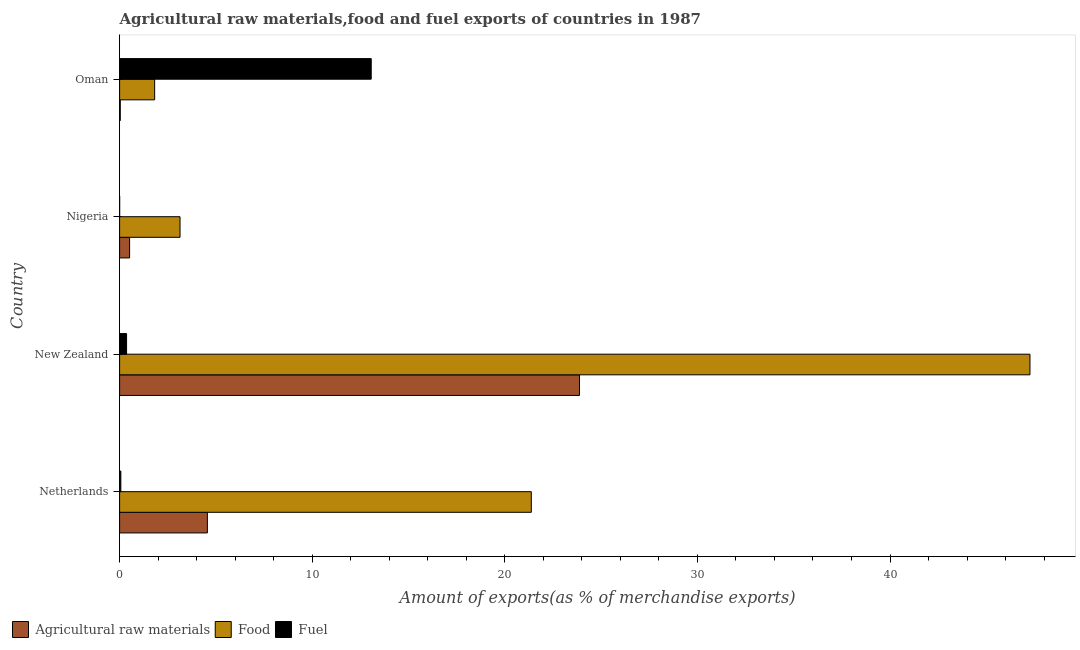How many different coloured bars are there?
Ensure brevity in your answer.  3. How many groups of bars are there?
Provide a short and direct response. 4. Are the number of bars per tick equal to the number of legend labels?
Offer a very short reply. Yes. Are the number of bars on each tick of the Y-axis equal?
Make the answer very short. Yes. How many bars are there on the 1st tick from the top?
Give a very brief answer. 3. What is the label of the 4th group of bars from the top?
Ensure brevity in your answer.  Netherlands. In how many cases, is the number of bars for a given country not equal to the number of legend labels?
Give a very brief answer. 0. What is the percentage of raw materials exports in New Zealand?
Your answer should be very brief. 23.88. Across all countries, what is the maximum percentage of fuel exports?
Keep it short and to the point. 13.06. Across all countries, what is the minimum percentage of raw materials exports?
Ensure brevity in your answer.  0.04. In which country was the percentage of raw materials exports maximum?
Make the answer very short. New Zealand. In which country was the percentage of fuel exports minimum?
Offer a very short reply. Nigeria. What is the total percentage of fuel exports in the graph?
Your answer should be very brief. 13.49. What is the difference between the percentage of food exports in New Zealand and that in Oman?
Your response must be concise. 45.45. What is the difference between the percentage of food exports in Netherlands and the percentage of fuel exports in Oman?
Ensure brevity in your answer.  8.31. What is the average percentage of food exports per country?
Offer a very short reply. 18.4. What is the difference between the percentage of food exports and percentage of fuel exports in Nigeria?
Your answer should be very brief. 3.13. In how many countries, is the percentage of food exports greater than 46 %?
Keep it short and to the point. 1. What is the ratio of the percentage of raw materials exports in Netherlands to that in Nigeria?
Your answer should be very brief. 8.77. Is the difference between the percentage of food exports in Nigeria and Oman greater than the difference between the percentage of raw materials exports in Nigeria and Oman?
Provide a short and direct response. Yes. What is the difference between the highest and the second highest percentage of raw materials exports?
Your answer should be very brief. 19.32. What is the difference between the highest and the lowest percentage of raw materials exports?
Your answer should be compact. 23.84. In how many countries, is the percentage of fuel exports greater than the average percentage of fuel exports taken over all countries?
Your response must be concise. 1. What does the 3rd bar from the top in New Zealand represents?
Make the answer very short. Agricultural raw materials. What does the 3rd bar from the bottom in New Zealand represents?
Keep it short and to the point. Fuel. Are all the bars in the graph horizontal?
Your answer should be very brief. Yes. Are the values on the major ticks of X-axis written in scientific E-notation?
Keep it short and to the point. No. Does the graph contain any zero values?
Offer a very short reply. No. Does the graph contain grids?
Keep it short and to the point. No. Where does the legend appear in the graph?
Your answer should be compact. Bottom left. How many legend labels are there?
Your response must be concise. 3. What is the title of the graph?
Make the answer very short. Agricultural raw materials,food and fuel exports of countries in 1987. What is the label or title of the X-axis?
Keep it short and to the point. Amount of exports(as % of merchandise exports). What is the Amount of exports(as % of merchandise exports) of Agricultural raw materials in Netherlands?
Offer a terse response. 4.56. What is the Amount of exports(as % of merchandise exports) in Food in Netherlands?
Ensure brevity in your answer.  21.38. What is the Amount of exports(as % of merchandise exports) in Fuel in Netherlands?
Make the answer very short. 0.06. What is the Amount of exports(as % of merchandise exports) in Agricultural raw materials in New Zealand?
Provide a succinct answer. 23.88. What is the Amount of exports(as % of merchandise exports) of Food in New Zealand?
Your response must be concise. 47.27. What is the Amount of exports(as % of merchandise exports) of Fuel in New Zealand?
Provide a short and direct response. 0.36. What is the Amount of exports(as % of merchandise exports) in Agricultural raw materials in Nigeria?
Offer a very short reply. 0.52. What is the Amount of exports(as % of merchandise exports) in Food in Nigeria?
Ensure brevity in your answer.  3.14. What is the Amount of exports(as % of merchandise exports) of Fuel in Nigeria?
Make the answer very short. 0. What is the Amount of exports(as % of merchandise exports) of Agricultural raw materials in Oman?
Give a very brief answer. 0.04. What is the Amount of exports(as % of merchandise exports) in Food in Oman?
Keep it short and to the point. 1.82. What is the Amount of exports(as % of merchandise exports) in Fuel in Oman?
Your answer should be compact. 13.06. Across all countries, what is the maximum Amount of exports(as % of merchandise exports) in Agricultural raw materials?
Offer a very short reply. 23.88. Across all countries, what is the maximum Amount of exports(as % of merchandise exports) of Food?
Offer a terse response. 47.27. Across all countries, what is the maximum Amount of exports(as % of merchandise exports) of Fuel?
Your answer should be very brief. 13.06. Across all countries, what is the minimum Amount of exports(as % of merchandise exports) in Agricultural raw materials?
Offer a very short reply. 0.04. Across all countries, what is the minimum Amount of exports(as % of merchandise exports) in Food?
Your answer should be very brief. 1.82. Across all countries, what is the minimum Amount of exports(as % of merchandise exports) in Fuel?
Ensure brevity in your answer.  0. What is the total Amount of exports(as % of merchandise exports) in Agricultural raw materials in the graph?
Provide a short and direct response. 28.99. What is the total Amount of exports(as % of merchandise exports) of Food in the graph?
Offer a terse response. 73.6. What is the total Amount of exports(as % of merchandise exports) in Fuel in the graph?
Your response must be concise. 13.49. What is the difference between the Amount of exports(as % of merchandise exports) of Agricultural raw materials in Netherlands and that in New Zealand?
Make the answer very short. -19.32. What is the difference between the Amount of exports(as % of merchandise exports) of Food in Netherlands and that in New Zealand?
Your response must be concise. -25.89. What is the difference between the Amount of exports(as % of merchandise exports) of Fuel in Netherlands and that in New Zealand?
Your response must be concise. -0.3. What is the difference between the Amount of exports(as % of merchandise exports) of Agricultural raw materials in Netherlands and that in Nigeria?
Offer a terse response. 4.04. What is the difference between the Amount of exports(as % of merchandise exports) of Food in Netherlands and that in Nigeria?
Your answer should be compact. 18.24. What is the difference between the Amount of exports(as % of merchandise exports) of Fuel in Netherlands and that in Nigeria?
Offer a terse response. 0.06. What is the difference between the Amount of exports(as % of merchandise exports) of Agricultural raw materials in Netherlands and that in Oman?
Keep it short and to the point. 4.52. What is the difference between the Amount of exports(as % of merchandise exports) in Food in Netherlands and that in Oman?
Provide a short and direct response. 19.56. What is the difference between the Amount of exports(as % of merchandise exports) in Fuel in Netherlands and that in Oman?
Make the answer very short. -13. What is the difference between the Amount of exports(as % of merchandise exports) in Agricultural raw materials in New Zealand and that in Nigeria?
Give a very brief answer. 23.36. What is the difference between the Amount of exports(as % of merchandise exports) in Food in New Zealand and that in Nigeria?
Give a very brief answer. 44.13. What is the difference between the Amount of exports(as % of merchandise exports) in Fuel in New Zealand and that in Nigeria?
Your answer should be very brief. 0.36. What is the difference between the Amount of exports(as % of merchandise exports) in Agricultural raw materials in New Zealand and that in Oman?
Your answer should be compact. 23.84. What is the difference between the Amount of exports(as % of merchandise exports) in Food in New Zealand and that in Oman?
Your response must be concise. 45.45. What is the difference between the Amount of exports(as % of merchandise exports) in Fuel in New Zealand and that in Oman?
Keep it short and to the point. -12.7. What is the difference between the Amount of exports(as % of merchandise exports) in Agricultural raw materials in Nigeria and that in Oman?
Offer a terse response. 0.48. What is the difference between the Amount of exports(as % of merchandise exports) of Food in Nigeria and that in Oman?
Provide a short and direct response. 1.32. What is the difference between the Amount of exports(as % of merchandise exports) of Fuel in Nigeria and that in Oman?
Offer a terse response. -13.06. What is the difference between the Amount of exports(as % of merchandise exports) of Agricultural raw materials in Netherlands and the Amount of exports(as % of merchandise exports) of Food in New Zealand?
Give a very brief answer. -42.71. What is the difference between the Amount of exports(as % of merchandise exports) in Agricultural raw materials in Netherlands and the Amount of exports(as % of merchandise exports) in Fuel in New Zealand?
Keep it short and to the point. 4.19. What is the difference between the Amount of exports(as % of merchandise exports) of Food in Netherlands and the Amount of exports(as % of merchandise exports) of Fuel in New Zealand?
Provide a succinct answer. 21.01. What is the difference between the Amount of exports(as % of merchandise exports) in Agricultural raw materials in Netherlands and the Amount of exports(as % of merchandise exports) in Food in Nigeria?
Provide a succinct answer. 1.42. What is the difference between the Amount of exports(as % of merchandise exports) of Agricultural raw materials in Netherlands and the Amount of exports(as % of merchandise exports) of Fuel in Nigeria?
Make the answer very short. 4.55. What is the difference between the Amount of exports(as % of merchandise exports) in Food in Netherlands and the Amount of exports(as % of merchandise exports) in Fuel in Nigeria?
Offer a terse response. 21.37. What is the difference between the Amount of exports(as % of merchandise exports) of Agricultural raw materials in Netherlands and the Amount of exports(as % of merchandise exports) of Food in Oman?
Provide a succinct answer. 2.74. What is the difference between the Amount of exports(as % of merchandise exports) in Agricultural raw materials in Netherlands and the Amount of exports(as % of merchandise exports) in Fuel in Oman?
Offer a terse response. -8.51. What is the difference between the Amount of exports(as % of merchandise exports) of Food in Netherlands and the Amount of exports(as % of merchandise exports) of Fuel in Oman?
Your response must be concise. 8.31. What is the difference between the Amount of exports(as % of merchandise exports) in Agricultural raw materials in New Zealand and the Amount of exports(as % of merchandise exports) in Food in Nigeria?
Provide a short and direct response. 20.74. What is the difference between the Amount of exports(as % of merchandise exports) in Agricultural raw materials in New Zealand and the Amount of exports(as % of merchandise exports) in Fuel in Nigeria?
Make the answer very short. 23.88. What is the difference between the Amount of exports(as % of merchandise exports) of Food in New Zealand and the Amount of exports(as % of merchandise exports) of Fuel in Nigeria?
Provide a succinct answer. 47.26. What is the difference between the Amount of exports(as % of merchandise exports) in Agricultural raw materials in New Zealand and the Amount of exports(as % of merchandise exports) in Food in Oman?
Your answer should be very brief. 22.06. What is the difference between the Amount of exports(as % of merchandise exports) in Agricultural raw materials in New Zealand and the Amount of exports(as % of merchandise exports) in Fuel in Oman?
Provide a succinct answer. 10.81. What is the difference between the Amount of exports(as % of merchandise exports) of Food in New Zealand and the Amount of exports(as % of merchandise exports) of Fuel in Oman?
Your answer should be compact. 34.2. What is the difference between the Amount of exports(as % of merchandise exports) in Agricultural raw materials in Nigeria and the Amount of exports(as % of merchandise exports) in Food in Oman?
Offer a very short reply. -1.3. What is the difference between the Amount of exports(as % of merchandise exports) in Agricultural raw materials in Nigeria and the Amount of exports(as % of merchandise exports) in Fuel in Oman?
Provide a short and direct response. -12.54. What is the difference between the Amount of exports(as % of merchandise exports) of Food in Nigeria and the Amount of exports(as % of merchandise exports) of Fuel in Oman?
Provide a succinct answer. -9.93. What is the average Amount of exports(as % of merchandise exports) in Agricultural raw materials per country?
Your answer should be very brief. 7.25. What is the average Amount of exports(as % of merchandise exports) of Food per country?
Make the answer very short. 18.4. What is the average Amount of exports(as % of merchandise exports) of Fuel per country?
Provide a short and direct response. 3.37. What is the difference between the Amount of exports(as % of merchandise exports) of Agricultural raw materials and Amount of exports(as % of merchandise exports) of Food in Netherlands?
Ensure brevity in your answer.  -16.82. What is the difference between the Amount of exports(as % of merchandise exports) in Agricultural raw materials and Amount of exports(as % of merchandise exports) in Fuel in Netherlands?
Provide a succinct answer. 4.49. What is the difference between the Amount of exports(as % of merchandise exports) in Food and Amount of exports(as % of merchandise exports) in Fuel in Netherlands?
Offer a very short reply. 21.31. What is the difference between the Amount of exports(as % of merchandise exports) in Agricultural raw materials and Amount of exports(as % of merchandise exports) in Food in New Zealand?
Give a very brief answer. -23.39. What is the difference between the Amount of exports(as % of merchandise exports) of Agricultural raw materials and Amount of exports(as % of merchandise exports) of Fuel in New Zealand?
Ensure brevity in your answer.  23.52. What is the difference between the Amount of exports(as % of merchandise exports) of Food and Amount of exports(as % of merchandise exports) of Fuel in New Zealand?
Your answer should be very brief. 46.9. What is the difference between the Amount of exports(as % of merchandise exports) of Agricultural raw materials and Amount of exports(as % of merchandise exports) of Food in Nigeria?
Offer a very short reply. -2.62. What is the difference between the Amount of exports(as % of merchandise exports) in Agricultural raw materials and Amount of exports(as % of merchandise exports) in Fuel in Nigeria?
Give a very brief answer. 0.52. What is the difference between the Amount of exports(as % of merchandise exports) of Food and Amount of exports(as % of merchandise exports) of Fuel in Nigeria?
Offer a very short reply. 3.14. What is the difference between the Amount of exports(as % of merchandise exports) in Agricultural raw materials and Amount of exports(as % of merchandise exports) in Food in Oman?
Offer a very short reply. -1.78. What is the difference between the Amount of exports(as % of merchandise exports) of Agricultural raw materials and Amount of exports(as % of merchandise exports) of Fuel in Oman?
Keep it short and to the point. -13.03. What is the difference between the Amount of exports(as % of merchandise exports) in Food and Amount of exports(as % of merchandise exports) in Fuel in Oman?
Offer a terse response. -11.24. What is the ratio of the Amount of exports(as % of merchandise exports) of Agricultural raw materials in Netherlands to that in New Zealand?
Make the answer very short. 0.19. What is the ratio of the Amount of exports(as % of merchandise exports) of Food in Netherlands to that in New Zealand?
Provide a succinct answer. 0.45. What is the ratio of the Amount of exports(as % of merchandise exports) in Fuel in Netherlands to that in New Zealand?
Your response must be concise. 0.18. What is the ratio of the Amount of exports(as % of merchandise exports) of Agricultural raw materials in Netherlands to that in Nigeria?
Offer a very short reply. 8.77. What is the ratio of the Amount of exports(as % of merchandise exports) in Food in Netherlands to that in Nigeria?
Provide a short and direct response. 6.81. What is the ratio of the Amount of exports(as % of merchandise exports) of Fuel in Netherlands to that in Nigeria?
Offer a terse response. 27.52. What is the ratio of the Amount of exports(as % of merchandise exports) of Agricultural raw materials in Netherlands to that in Oman?
Offer a very short reply. 128.23. What is the ratio of the Amount of exports(as % of merchandise exports) in Food in Netherlands to that in Oman?
Offer a very short reply. 11.74. What is the ratio of the Amount of exports(as % of merchandise exports) in Fuel in Netherlands to that in Oman?
Your answer should be compact. 0. What is the ratio of the Amount of exports(as % of merchandise exports) in Agricultural raw materials in New Zealand to that in Nigeria?
Ensure brevity in your answer.  45.95. What is the ratio of the Amount of exports(as % of merchandise exports) of Food in New Zealand to that in Nigeria?
Make the answer very short. 15.06. What is the ratio of the Amount of exports(as % of merchandise exports) of Fuel in New Zealand to that in Nigeria?
Make the answer very short. 155.26. What is the ratio of the Amount of exports(as % of merchandise exports) in Agricultural raw materials in New Zealand to that in Oman?
Make the answer very short. 671.87. What is the ratio of the Amount of exports(as % of merchandise exports) of Food in New Zealand to that in Oman?
Your response must be concise. 25.97. What is the ratio of the Amount of exports(as % of merchandise exports) of Fuel in New Zealand to that in Oman?
Your answer should be compact. 0.03. What is the ratio of the Amount of exports(as % of merchandise exports) of Agricultural raw materials in Nigeria to that in Oman?
Provide a short and direct response. 14.62. What is the ratio of the Amount of exports(as % of merchandise exports) in Food in Nigeria to that in Oman?
Give a very brief answer. 1.72. What is the difference between the highest and the second highest Amount of exports(as % of merchandise exports) in Agricultural raw materials?
Your response must be concise. 19.32. What is the difference between the highest and the second highest Amount of exports(as % of merchandise exports) of Food?
Your answer should be compact. 25.89. What is the difference between the highest and the second highest Amount of exports(as % of merchandise exports) in Fuel?
Your response must be concise. 12.7. What is the difference between the highest and the lowest Amount of exports(as % of merchandise exports) in Agricultural raw materials?
Your answer should be very brief. 23.84. What is the difference between the highest and the lowest Amount of exports(as % of merchandise exports) in Food?
Your response must be concise. 45.45. What is the difference between the highest and the lowest Amount of exports(as % of merchandise exports) in Fuel?
Provide a succinct answer. 13.06. 